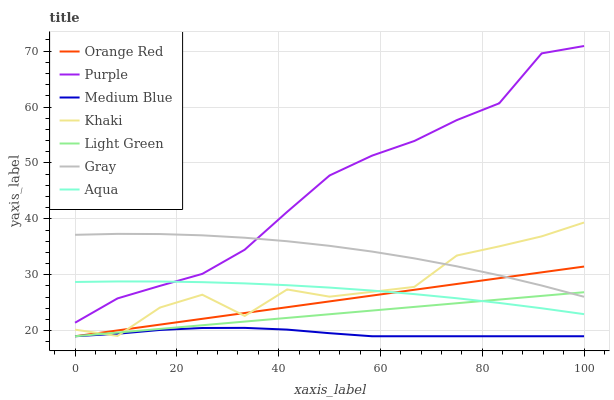Does Medium Blue have the minimum area under the curve?
Answer yes or no. Yes. Does Purple have the maximum area under the curve?
Answer yes or no. Yes. Does Khaki have the minimum area under the curve?
Answer yes or no. No. Does Khaki have the maximum area under the curve?
Answer yes or no. No. Is Light Green the smoothest?
Answer yes or no. Yes. Is Khaki the roughest?
Answer yes or no. Yes. Is Purple the smoothest?
Answer yes or no. No. Is Purple the roughest?
Answer yes or no. No. Does Medium Blue have the lowest value?
Answer yes or no. Yes. Does Khaki have the lowest value?
Answer yes or no. No. Does Purple have the highest value?
Answer yes or no. Yes. Does Khaki have the highest value?
Answer yes or no. No. Is Medium Blue less than Aqua?
Answer yes or no. Yes. Is Gray greater than Medium Blue?
Answer yes or no. Yes. Does Khaki intersect Light Green?
Answer yes or no. Yes. Is Khaki less than Light Green?
Answer yes or no. No. Is Khaki greater than Light Green?
Answer yes or no. No. Does Medium Blue intersect Aqua?
Answer yes or no. No. 